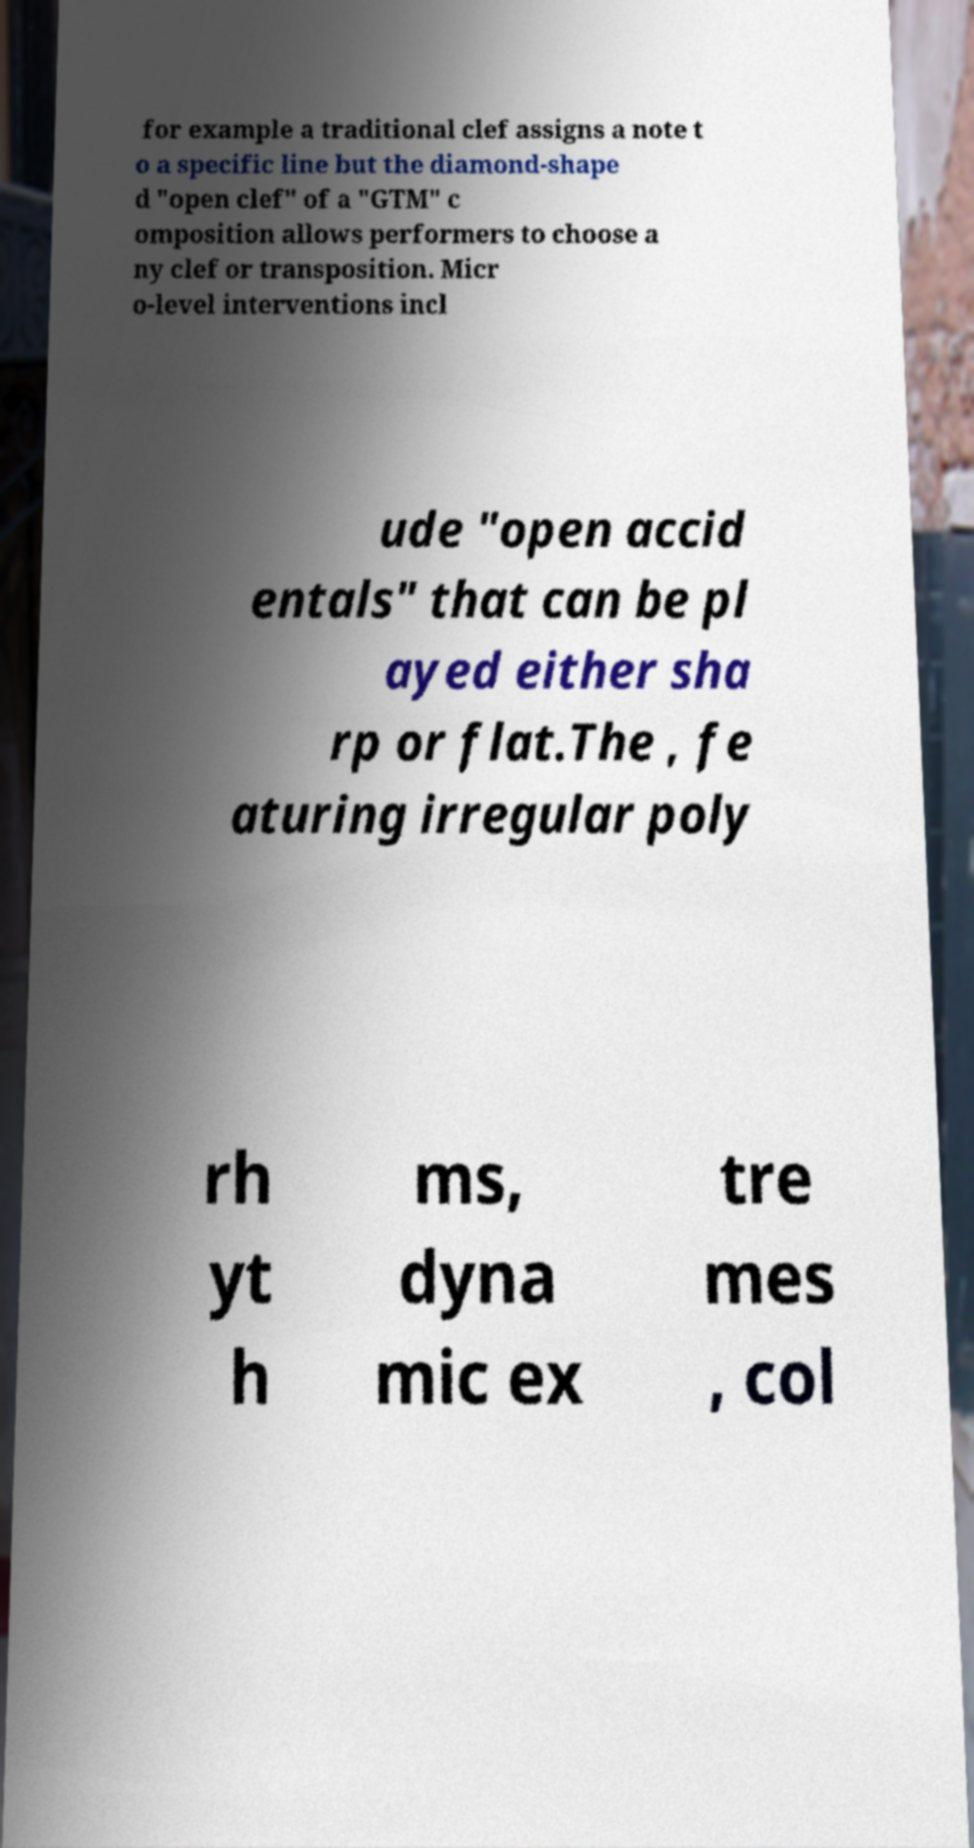Can you read and provide the text displayed in the image?This photo seems to have some interesting text. Can you extract and type it out for me? for example a traditional clef assigns a note t o a specific line but the diamond-shape d "open clef" of a "GTM" c omposition allows performers to choose a ny clef or transposition. Micr o-level interventions incl ude "open accid entals" that can be pl ayed either sha rp or flat.The , fe aturing irregular poly rh yt h ms, dyna mic ex tre mes , col 